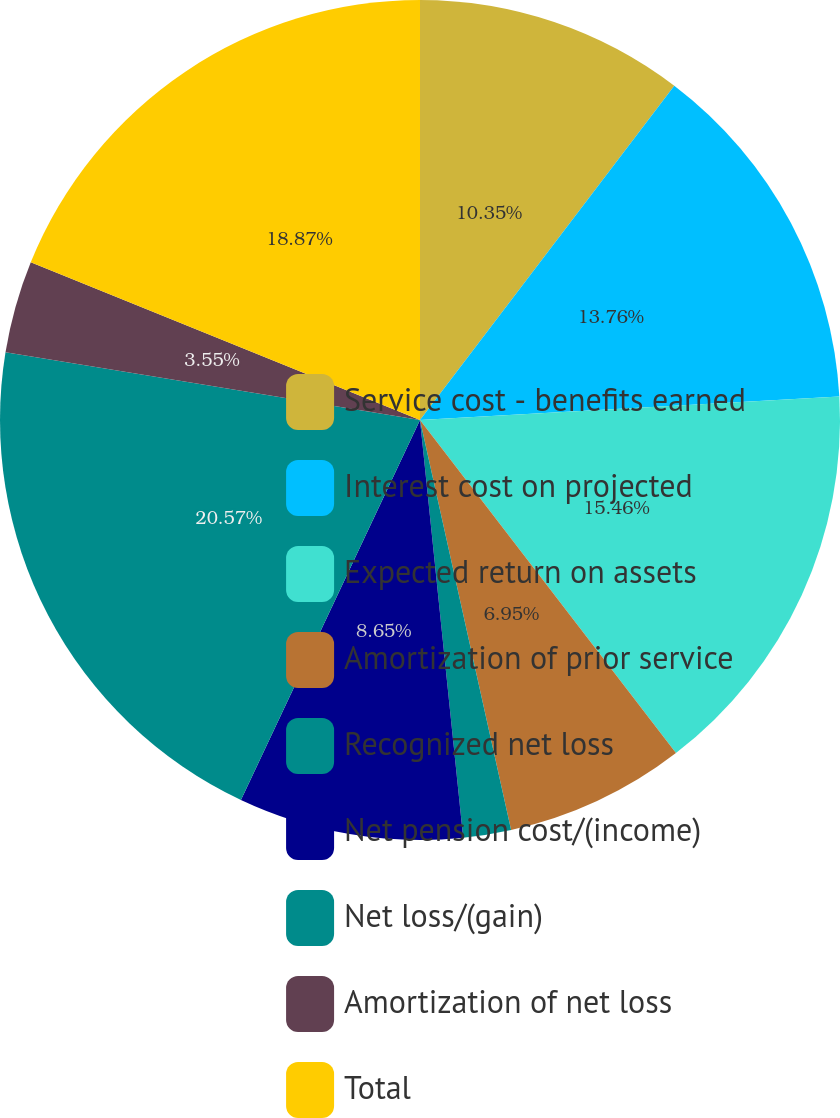<chart> <loc_0><loc_0><loc_500><loc_500><pie_chart><fcel>Service cost - benefits earned<fcel>Interest cost on projected<fcel>Expected return on assets<fcel>Amortization of prior service<fcel>Recognized net loss<fcel>Net pension cost/(income)<fcel>Net loss/(gain)<fcel>Amortization of net loss<fcel>Total<nl><fcel>10.35%<fcel>13.76%<fcel>15.46%<fcel>6.95%<fcel>1.84%<fcel>8.65%<fcel>20.57%<fcel>3.55%<fcel>18.87%<nl></chart> 